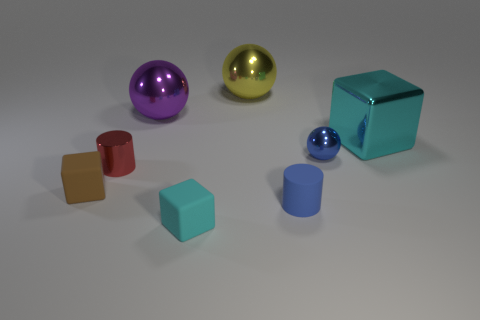What is the color of the small shiny thing on the left side of the tiny blue object that is in front of the shiny ball that is in front of the metallic cube?
Provide a succinct answer. Red. What number of other objects are the same material as the big purple sphere?
Offer a terse response. 4. Does the rubber object that is to the right of the yellow shiny sphere have the same shape as the large cyan shiny object?
Make the answer very short. No. How many big things are either rubber spheres or matte blocks?
Make the answer very short. 0. Are there the same number of large yellow metal balls in front of the small brown cube and big yellow things that are right of the big cyan cube?
Offer a very short reply. Yes. What number of other objects are there of the same color as the large block?
Your response must be concise. 1. Do the large metal block and the sphere that is in front of the big metallic block have the same color?
Your answer should be very brief. No. How many purple objects are metallic cylinders or big cylinders?
Give a very brief answer. 0. Are there an equal number of tiny red things in front of the cyan rubber thing and large yellow metal objects?
Your answer should be very brief. No. Are there any other things that are the same size as the yellow metal ball?
Your answer should be very brief. Yes. 